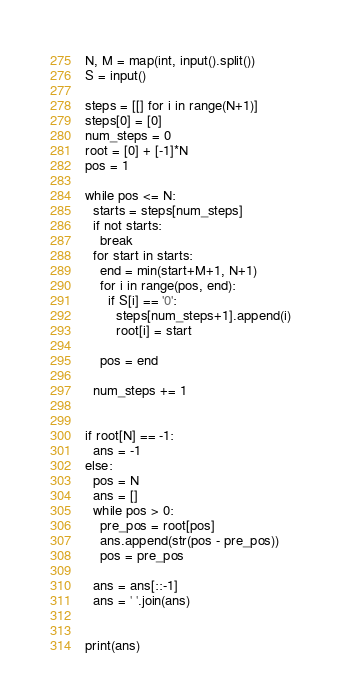Convert code to text. <code><loc_0><loc_0><loc_500><loc_500><_Python_>N, M = map(int, input().split())
S = input()

steps = [[] for i in range(N+1)]
steps[0] = [0]
num_steps = 0
root = [0] + [-1]*N
pos = 1

while pos <= N:
  starts = steps[num_steps]
  if not starts:
    break
  for start in starts:
    end = min(start+M+1, N+1)
    for i in range(pos, end):
      if S[i] == '0':
        steps[num_steps+1].append(i)
        root[i] = start
    
    pos = end
  
  num_steps += 1


if root[N] == -1:
  ans = -1
else:
  pos = N
  ans = []
  while pos > 0:
    pre_pos = root[pos]
    ans.append(str(pos - pre_pos))
    pos = pre_pos
  
  ans = ans[::-1]
  ans = ' '.join(ans)


print(ans)</code> 